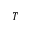Convert formula to latex. <formula><loc_0><loc_0><loc_500><loc_500>T</formula> 